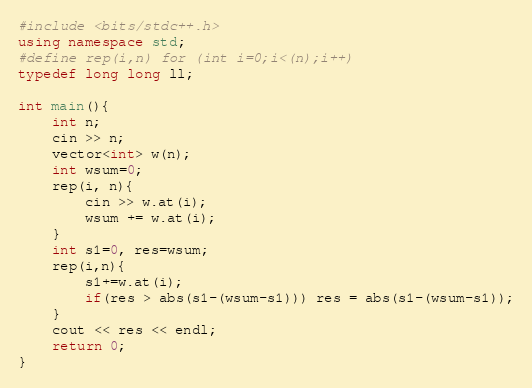Convert code to text. <code><loc_0><loc_0><loc_500><loc_500><_C++_>#include <bits/stdc++.h>
using namespace std;
#define rep(i,n) for (int i=0;i<(n);i++)
typedef long long ll;

int main(){
    int n;
    cin >> n;
    vector<int> w(n);
    int wsum=0;
    rep(i, n){
        cin >> w.at(i);
        wsum += w.at(i);
    }
    int s1=0, res=wsum;
    rep(i,n){
        s1+=w.at(i);
        if(res > abs(s1-(wsum-s1))) res = abs(s1-(wsum-s1));
    }
    cout << res << endl;
    return 0;
}</code> 